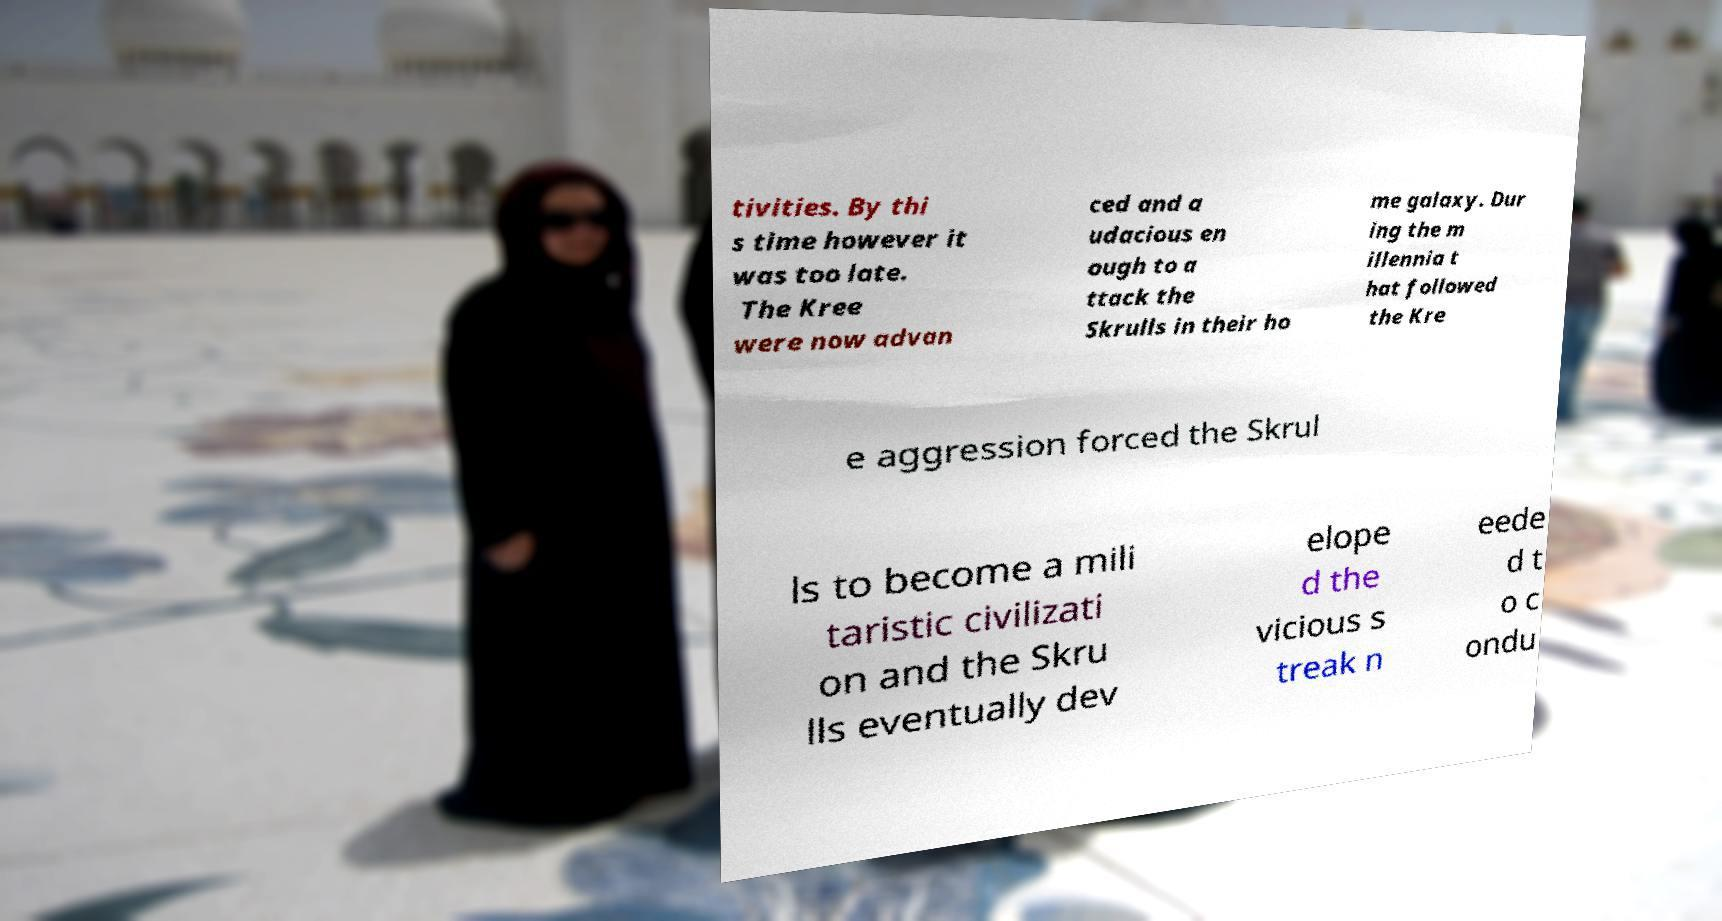Please identify and transcribe the text found in this image. tivities. By thi s time however it was too late. The Kree were now advan ced and a udacious en ough to a ttack the Skrulls in their ho me galaxy. Dur ing the m illennia t hat followed the Kre e aggression forced the Skrul ls to become a mili taristic civilizati on and the Skru lls eventually dev elope d the vicious s treak n eede d t o c ondu 